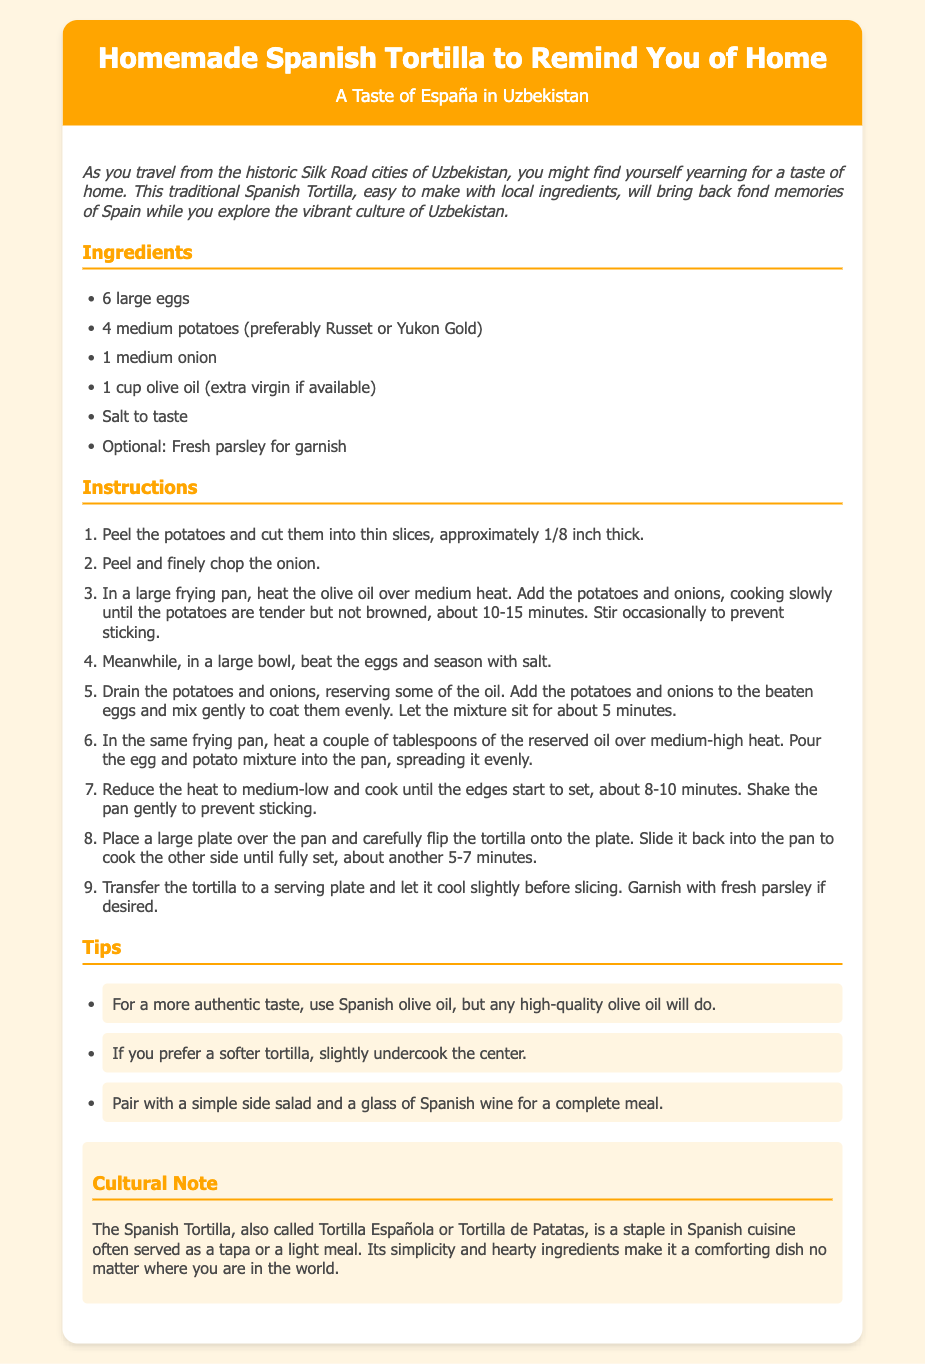what is the title of the recipe? The title of the recipe is displayed prominently at the top of the document, introducing the dish being prepared.
Answer: Homemade Spanish Tortilla to Remind You of Home how many large eggs are needed? The ingredients section lists the required items along with their quantities.
Answer: 6 large eggs what type of potatoes is preferred? The ingredients mention a preference for specific types of potatoes for optimal flavor and texture in the dish.
Answer: Russet or Yukon Gold how long should the edges of the tortilla be cooked? The instructions detail the cooking timeframe needed for the tortilla while it sets, providing a guideline for preparation.
Answer: 8-10 minutes what garnish is optional for the dish? The ingredients section includes an optional element that can enhance the presentation of the dish.
Answer: Fresh parsley what is a cultural note about the Spanish Tortilla? A section in the document provides context about the dish, highlighting its cultural significance and role in cuisine.
Answer: A staple in Spanish cuisine often served as a tapa what should be served alongside the tortilla for a complete meal? The tips section suggests a pairing to complement the dish, enhancing the dining experience.
Answer: Simple side salad and a glass of Spanish wine what is the cooking method for the potatoes and onions? The instructions indicate how to prepare the primary ingredients before combining them with eggs, which is essential for the recipe.
Answer: Cooking slowly in olive oil what is the maximum width of the recipe card? The design ensures the recipe card has a set width for optimal viewing, which is relevant for mobile or desktop formats.
Answer: 800 pixels 